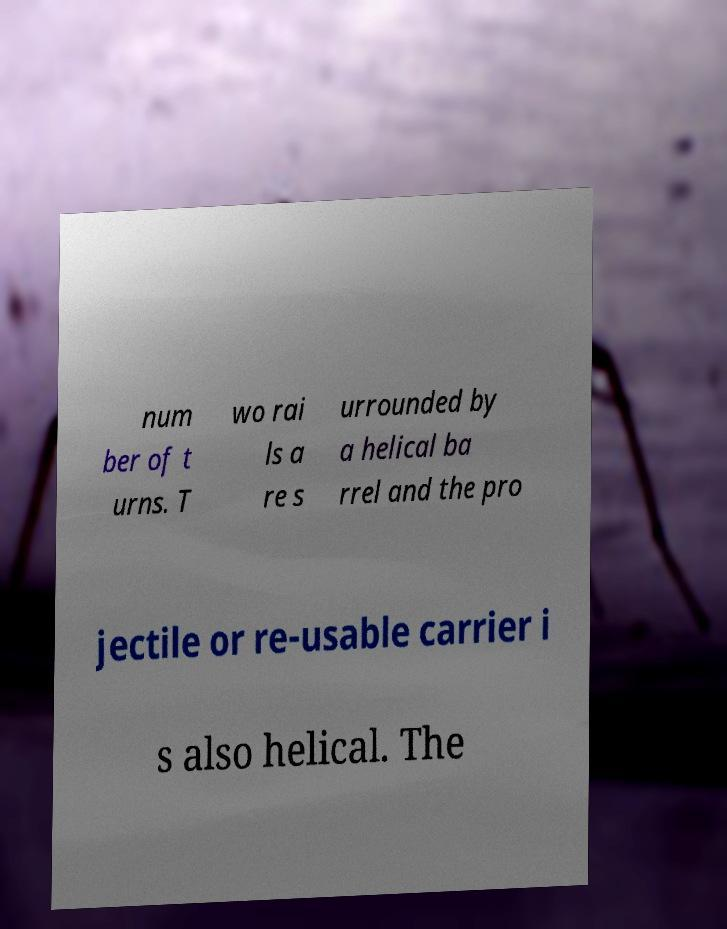I need the written content from this picture converted into text. Can you do that? num ber of t urns. T wo rai ls a re s urrounded by a helical ba rrel and the pro jectile or re-usable carrier i s also helical. The 